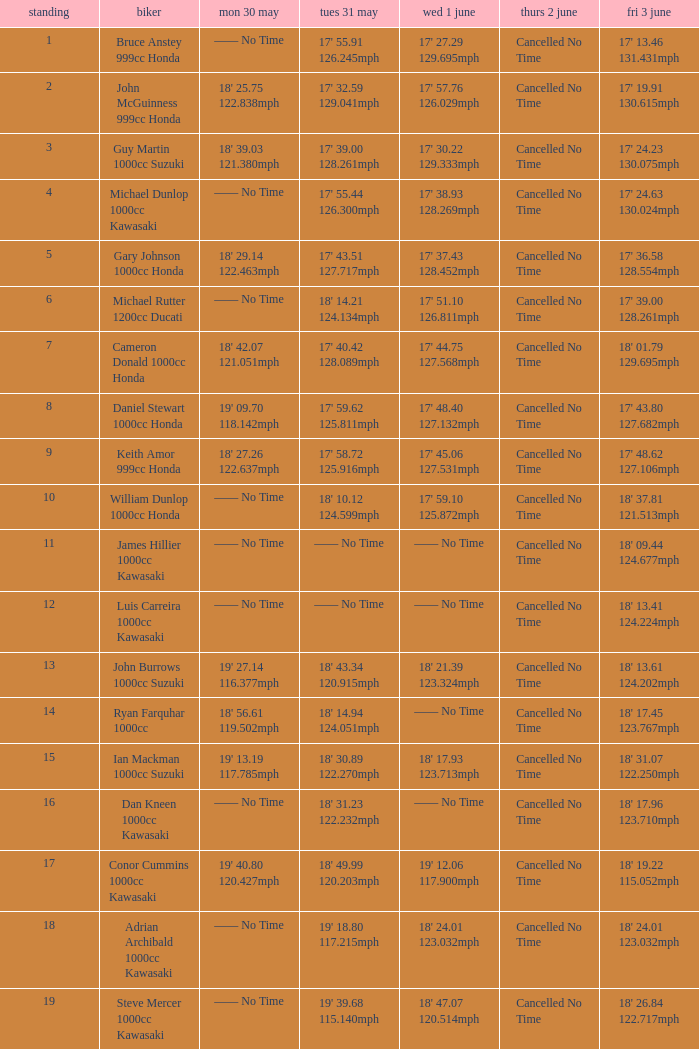What is the Mon 30 May time for the rider whose Fri 3 June time was 17' 13.46 131.431mph? —— No Time. 